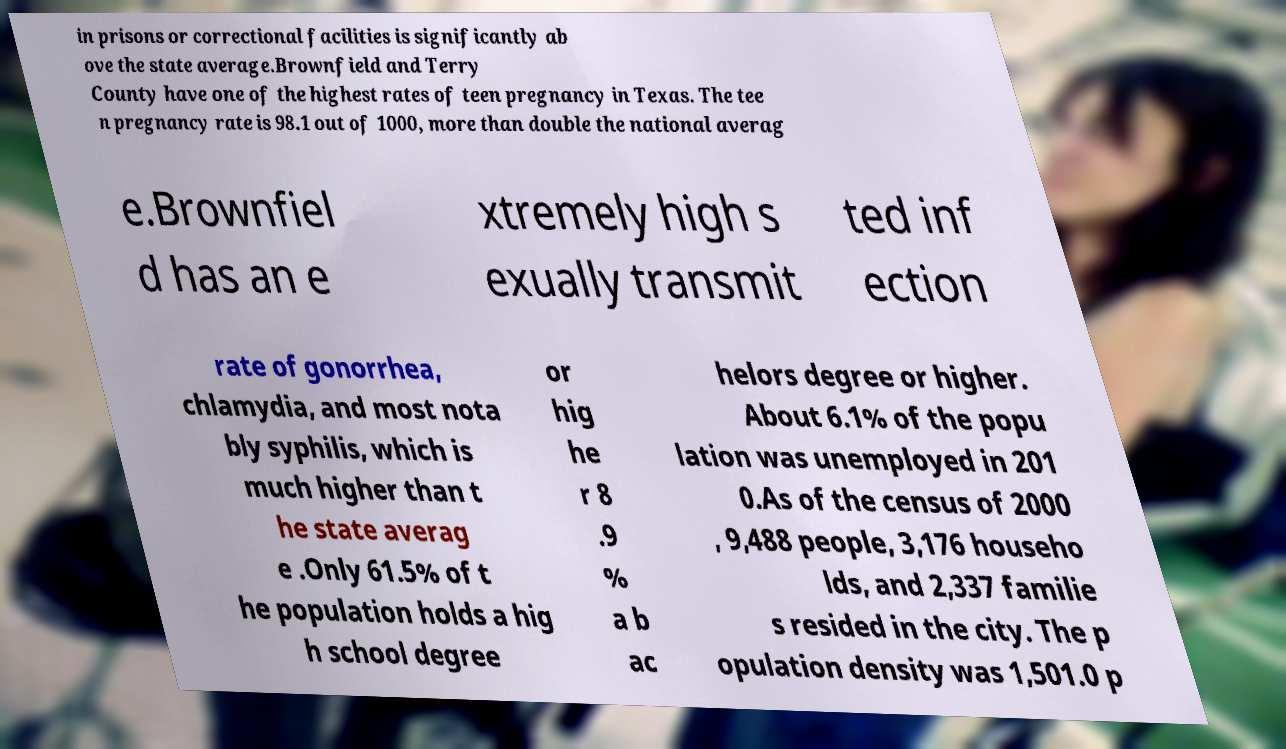I need the written content from this picture converted into text. Can you do that? in prisons or correctional facilities is significantly ab ove the state average.Brownfield and Terry County have one of the highest rates of teen pregnancy in Texas. The tee n pregnancy rate is 98.1 out of 1000, more than double the national averag e.Brownfiel d has an e xtremely high s exually transmit ted inf ection rate of gonorrhea, chlamydia, and most nota bly syphilis, which is much higher than t he state averag e .Only 61.5% of t he population holds a hig h school degree or hig he r 8 .9 % a b ac helors degree or higher. About 6.1% of the popu lation was unemployed in 201 0.As of the census of 2000 , 9,488 people, 3,176 househo lds, and 2,337 familie s resided in the city. The p opulation density was 1,501.0 p 